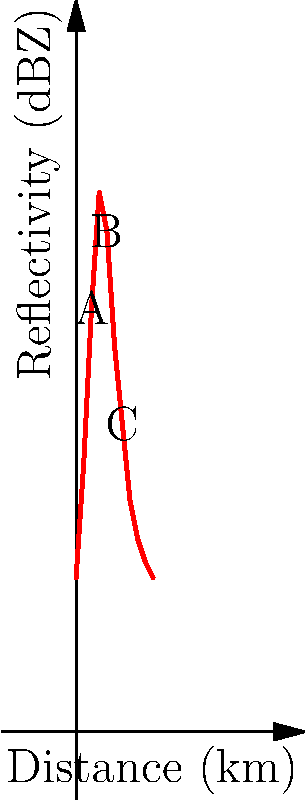The graph shows radar reflectivity values (in dBZ) along a cross-section through a tropical thunderstorm. Which region (A, B, or C) most likely represents the area of heaviest precipitation, and why? To determine the area of heaviest precipitation, we need to analyze the radar reflectivity pattern:

1. Radar reflectivity (measured in dBZ) is directly related to precipitation intensity. Higher dBZ values generally indicate heavier precipitation.

2. Examine the three labeled points:
   A (2 km, 55 dBZ)
   B (4 km, 65 dBZ)
   C (6 km, 40 dBZ)

3. Compare the dBZ values:
   B has the highest value at 65 dBZ
   A is second at 55 dBZ
   C is lowest at 40 dBZ

4. In tropical thunderstorms, reflectivity values:
   • 40-50 dBZ typically indicate moderate rain
   • >50 dBZ usually indicate heavy rain
   • >60 dBZ often associated with very heavy rain or hail

5. Region B, with 65 dBZ, falls into the very heavy rain/hail category, indicating the most intense precipitation.

6. The overall shape of the reflectivity curve also supports this conclusion, as it peaks at point B.

Therefore, region B most likely represents the area of heaviest precipitation due to its significantly higher reflectivity value.
Answer: Region B, due to highest reflectivity (65 dBZ) indicating most intense precipitation. 